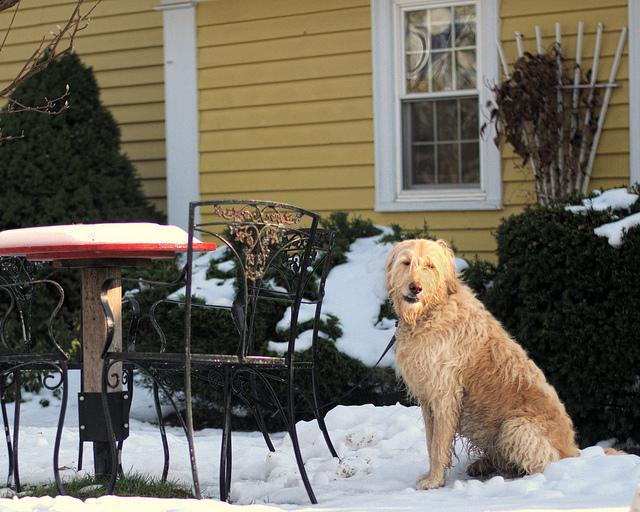What famous animal does this one most closely resemble?

Choices:
A) dumbo
B) garfield
C) free willy
D) benji benji 